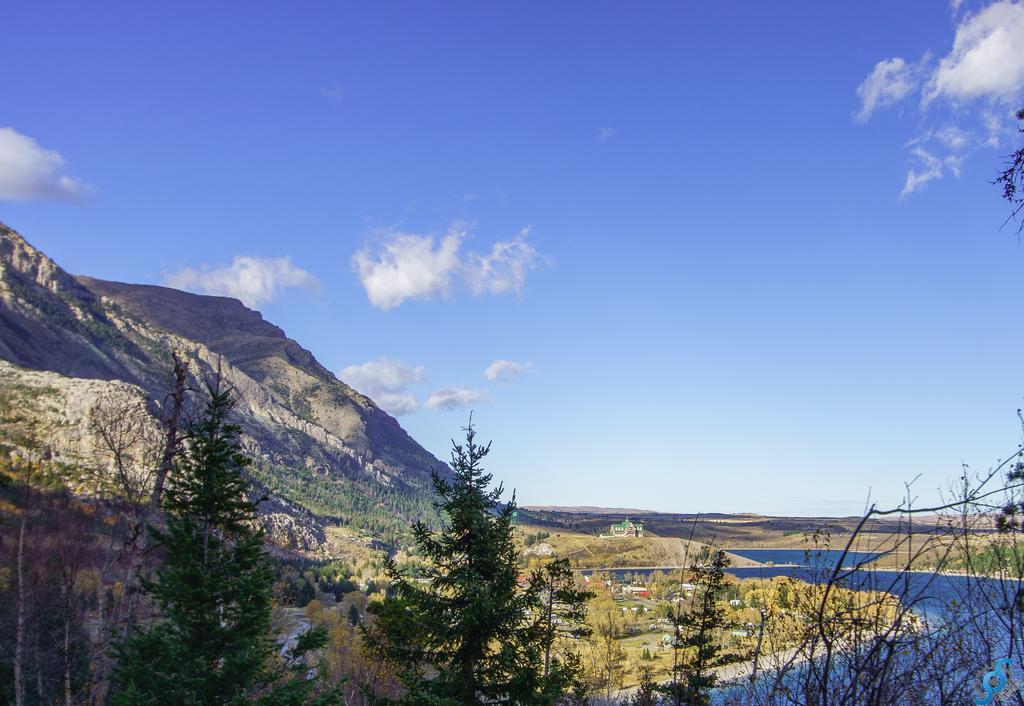Describe this image in one or two sentences. This is an outside view. At the bottom there are few trees. On the right side there is a river and I can see few houses on the ground. On the left side there are few hills. At the top of the image I can see the sky and clouds. 